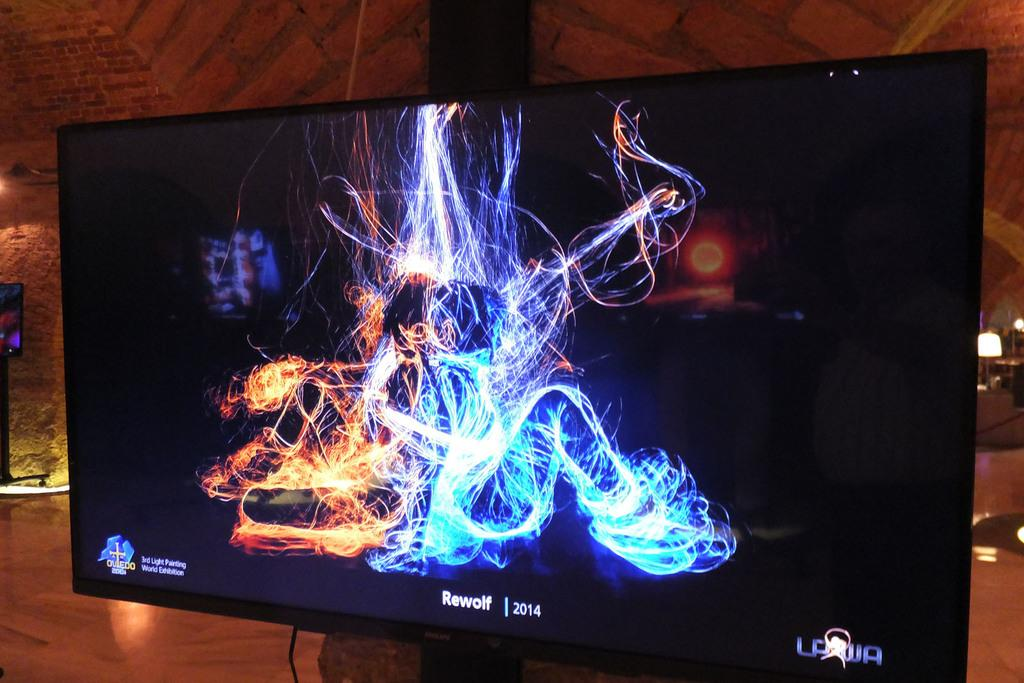<image>
Present a compact description of the photo's key features. A monitor displays a colorful image along with the text "Rewolf 2014". 